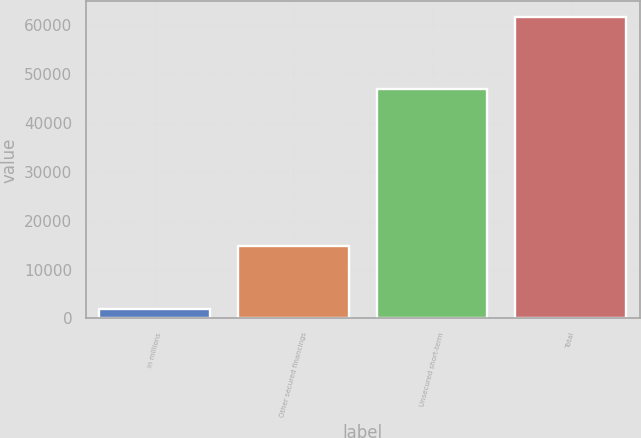<chart> <loc_0><loc_0><loc_500><loc_500><bar_chart><fcel>in millions<fcel>Other secured financings<fcel>Unsecured short-term<fcel>Total<nl><fcel>2017<fcel>14896<fcel>46922<fcel>61818<nl></chart> 